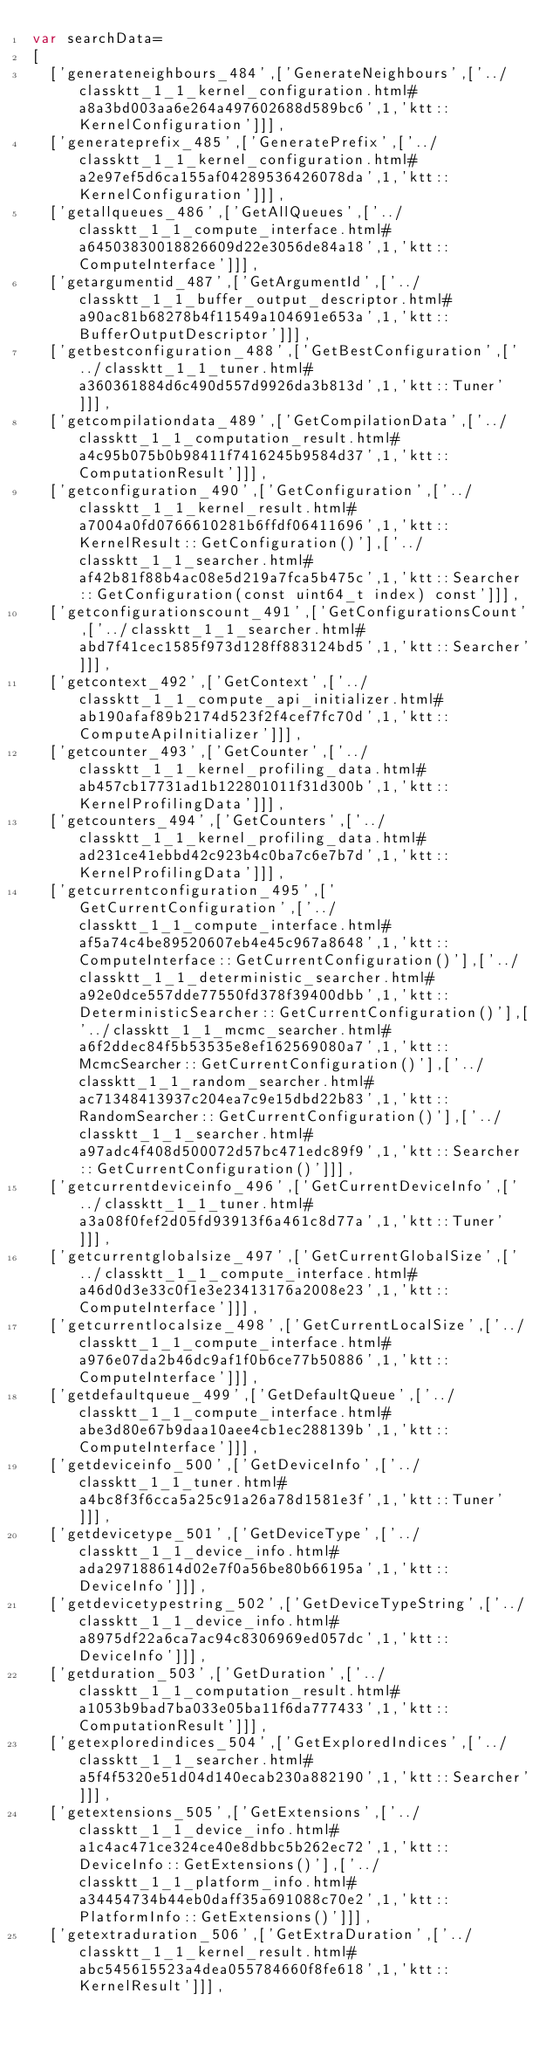Convert code to text. <code><loc_0><loc_0><loc_500><loc_500><_JavaScript_>var searchData=
[
  ['generateneighbours_484',['GenerateNeighbours',['../classktt_1_1_kernel_configuration.html#a8a3bd003aa6e264a497602688d589bc6',1,'ktt::KernelConfiguration']]],
  ['generateprefix_485',['GeneratePrefix',['../classktt_1_1_kernel_configuration.html#a2e97ef5d6ca155af04289536426078da',1,'ktt::KernelConfiguration']]],
  ['getallqueues_486',['GetAllQueues',['../classktt_1_1_compute_interface.html#a64503830018826609d22e3056de84a18',1,'ktt::ComputeInterface']]],
  ['getargumentid_487',['GetArgumentId',['../classktt_1_1_buffer_output_descriptor.html#a90ac81b68278b4f11549a104691e653a',1,'ktt::BufferOutputDescriptor']]],
  ['getbestconfiguration_488',['GetBestConfiguration',['../classktt_1_1_tuner.html#a360361884d6c490d557d9926da3b813d',1,'ktt::Tuner']]],
  ['getcompilationdata_489',['GetCompilationData',['../classktt_1_1_computation_result.html#a4c95b075b0b98411f7416245b9584d37',1,'ktt::ComputationResult']]],
  ['getconfiguration_490',['GetConfiguration',['../classktt_1_1_kernel_result.html#a7004a0fd0766610281b6ffdf06411696',1,'ktt::KernelResult::GetConfiguration()'],['../classktt_1_1_searcher.html#af42b81f88b4ac08e5d219a7fca5b475c',1,'ktt::Searcher::GetConfiguration(const uint64_t index) const']]],
  ['getconfigurationscount_491',['GetConfigurationsCount',['../classktt_1_1_searcher.html#abd7f41cec1585f973d128ff883124bd5',1,'ktt::Searcher']]],
  ['getcontext_492',['GetContext',['../classktt_1_1_compute_api_initializer.html#ab190afaf89b2174d523f2f4cef7fc70d',1,'ktt::ComputeApiInitializer']]],
  ['getcounter_493',['GetCounter',['../classktt_1_1_kernel_profiling_data.html#ab457cb17731ad1b122801011f31d300b',1,'ktt::KernelProfilingData']]],
  ['getcounters_494',['GetCounters',['../classktt_1_1_kernel_profiling_data.html#ad231ce41ebbd42c923b4c0ba7c6e7b7d',1,'ktt::KernelProfilingData']]],
  ['getcurrentconfiguration_495',['GetCurrentConfiguration',['../classktt_1_1_compute_interface.html#af5a74c4be89520607eb4e45c967a8648',1,'ktt::ComputeInterface::GetCurrentConfiguration()'],['../classktt_1_1_deterministic_searcher.html#a92e0dce557dde77550fd378f39400dbb',1,'ktt::DeterministicSearcher::GetCurrentConfiguration()'],['../classktt_1_1_mcmc_searcher.html#a6f2ddec84f5b53535e8ef162569080a7',1,'ktt::McmcSearcher::GetCurrentConfiguration()'],['../classktt_1_1_random_searcher.html#ac71348413937c204ea7c9e15dbd22b83',1,'ktt::RandomSearcher::GetCurrentConfiguration()'],['../classktt_1_1_searcher.html#a97adc4f408d500072d57bc471edc89f9',1,'ktt::Searcher::GetCurrentConfiguration()']]],
  ['getcurrentdeviceinfo_496',['GetCurrentDeviceInfo',['../classktt_1_1_tuner.html#a3a08f0fef2d05fd93913f6a461c8d77a',1,'ktt::Tuner']]],
  ['getcurrentglobalsize_497',['GetCurrentGlobalSize',['../classktt_1_1_compute_interface.html#a46d0d3e33c0f1e3e23413176a2008e23',1,'ktt::ComputeInterface']]],
  ['getcurrentlocalsize_498',['GetCurrentLocalSize',['../classktt_1_1_compute_interface.html#a976e07da2b46dc9af1f0b6ce77b50886',1,'ktt::ComputeInterface']]],
  ['getdefaultqueue_499',['GetDefaultQueue',['../classktt_1_1_compute_interface.html#abe3d80e67b9daa10aee4cb1ec288139b',1,'ktt::ComputeInterface']]],
  ['getdeviceinfo_500',['GetDeviceInfo',['../classktt_1_1_tuner.html#a4bc8f3f6cca5a25c91a26a78d1581e3f',1,'ktt::Tuner']]],
  ['getdevicetype_501',['GetDeviceType',['../classktt_1_1_device_info.html#ada297188614d02e7f0a56be80b66195a',1,'ktt::DeviceInfo']]],
  ['getdevicetypestring_502',['GetDeviceTypeString',['../classktt_1_1_device_info.html#a8975df22a6ca7ac94c8306969ed057dc',1,'ktt::DeviceInfo']]],
  ['getduration_503',['GetDuration',['../classktt_1_1_computation_result.html#a1053b9bad7ba033e05ba11f6da777433',1,'ktt::ComputationResult']]],
  ['getexploredindices_504',['GetExploredIndices',['../classktt_1_1_searcher.html#a5f4f5320e51d04d140ecab230a882190',1,'ktt::Searcher']]],
  ['getextensions_505',['GetExtensions',['../classktt_1_1_device_info.html#a1c4ac471ce324ce40e8dbbc5b262ec72',1,'ktt::DeviceInfo::GetExtensions()'],['../classktt_1_1_platform_info.html#a34454734b44eb0daff35a691088c70e2',1,'ktt::PlatformInfo::GetExtensions()']]],
  ['getextraduration_506',['GetExtraDuration',['../classktt_1_1_kernel_result.html#abc545615523a4dea055784660f8fe618',1,'ktt::KernelResult']]],</code> 